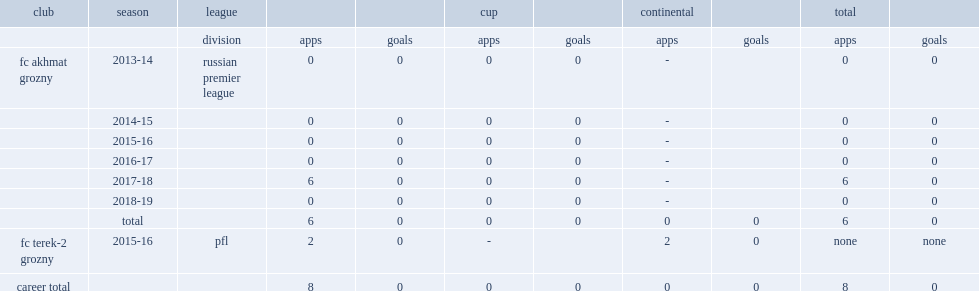Ayub batsuyev has been on the roster of fc akhmat grozny since 2013, which league did he make his debut for the club? Russian premier league. 